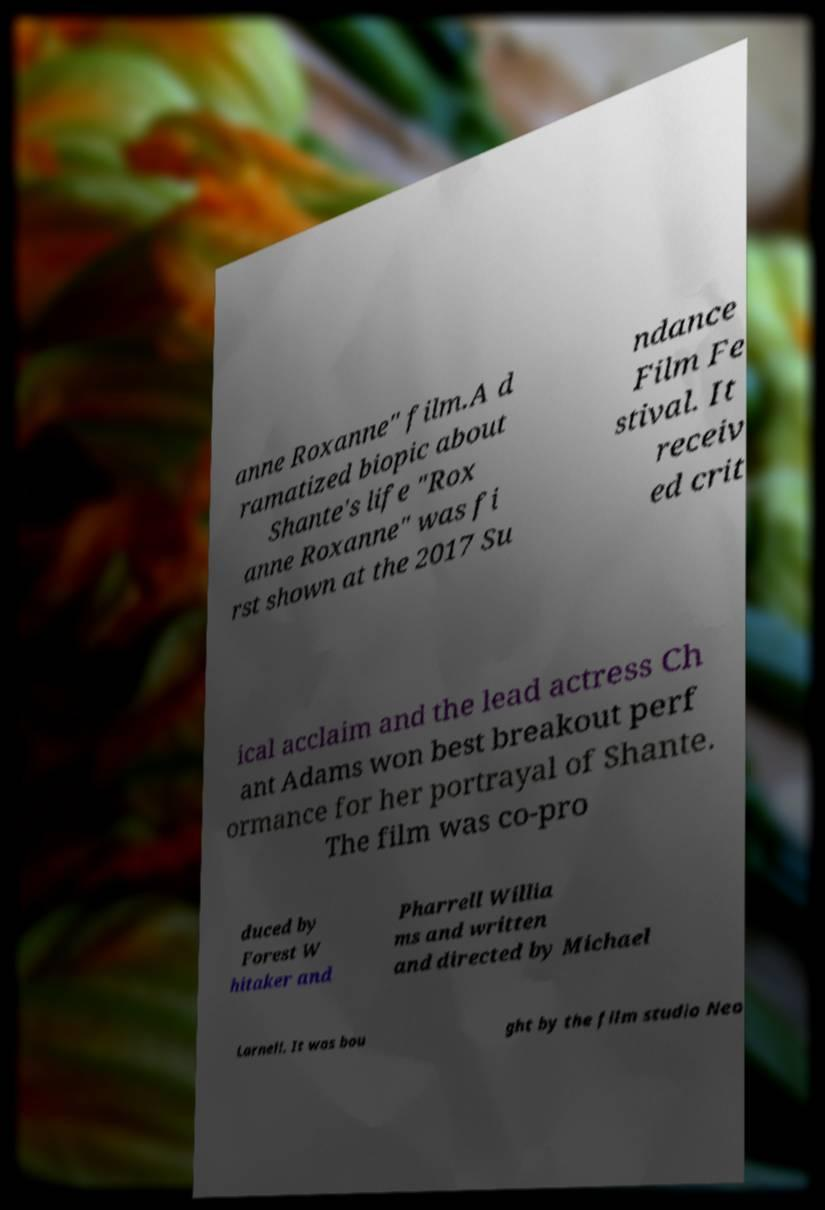Please read and relay the text visible in this image. What does it say? anne Roxanne" film.A d ramatized biopic about Shante's life "Rox anne Roxanne" was fi rst shown at the 2017 Su ndance Film Fe stival. It receiv ed crit ical acclaim and the lead actress Ch ant Adams won best breakout perf ormance for her portrayal of Shante. The film was co-pro duced by Forest W hitaker and Pharrell Willia ms and written and directed by Michael Larnell. It was bou ght by the film studio Neo 